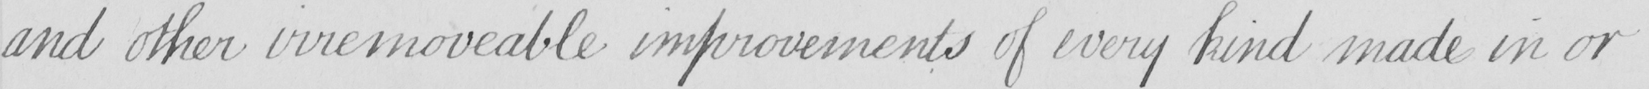Can you tell me what this handwritten text says? and other irremoveable improvements of every kind made in or 